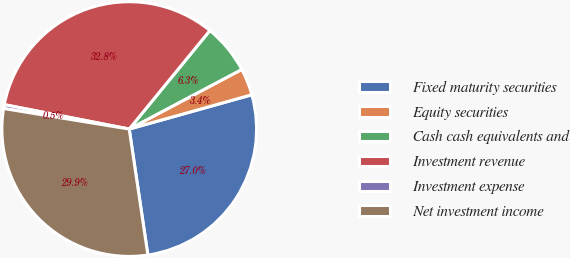Convert chart. <chart><loc_0><loc_0><loc_500><loc_500><pie_chart><fcel>Fixed maturity securities<fcel>Equity securities<fcel>Cash cash equivalents and<fcel>Investment revenue<fcel>Investment expense<fcel>Net investment income<nl><fcel>27.0%<fcel>3.41%<fcel>6.33%<fcel>32.84%<fcel>0.49%<fcel>29.92%<nl></chart> 